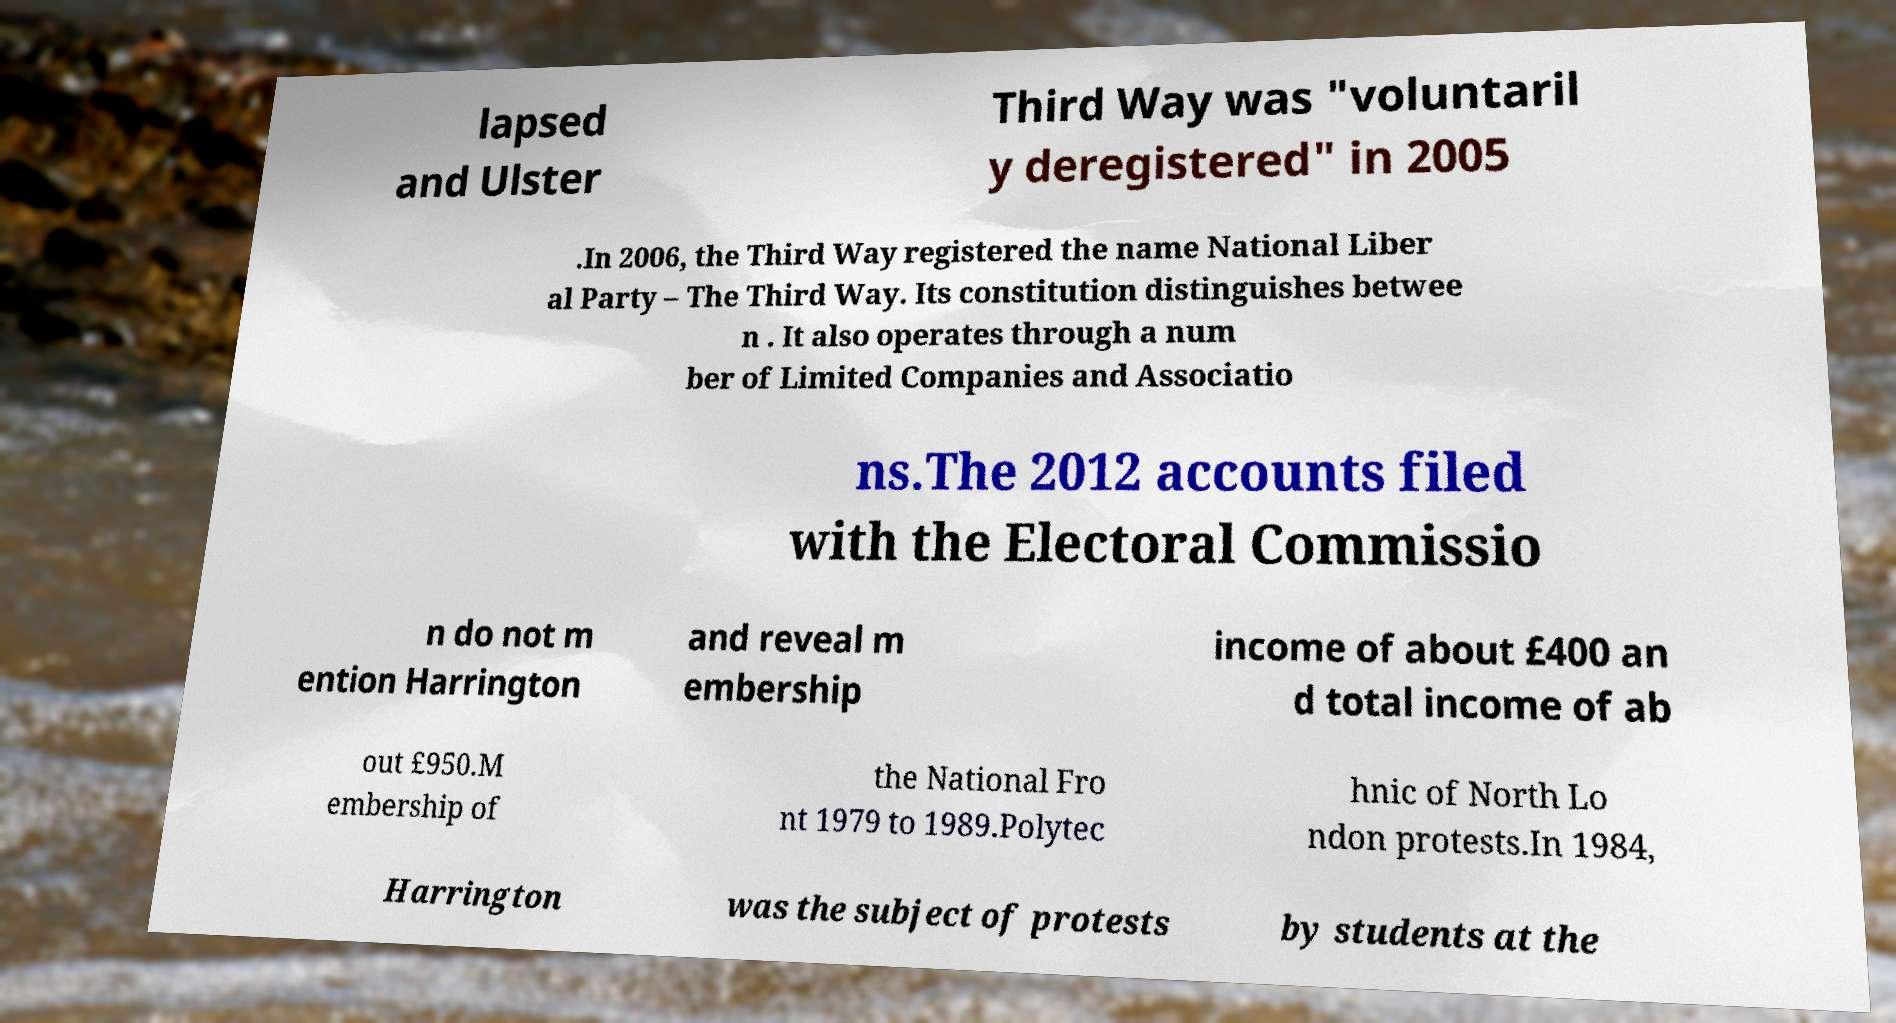Please identify and transcribe the text found in this image. lapsed and Ulster Third Way was "voluntaril y deregistered" in 2005 .In 2006, the Third Way registered the name National Liber al Party – The Third Way. Its constitution distinguishes betwee n . It also operates through a num ber of Limited Companies and Associatio ns.The 2012 accounts filed with the Electoral Commissio n do not m ention Harrington and reveal m embership income of about £400 an d total income of ab out £950.M embership of the National Fro nt 1979 to 1989.Polytec hnic of North Lo ndon protests.In 1984, Harrington was the subject of protests by students at the 